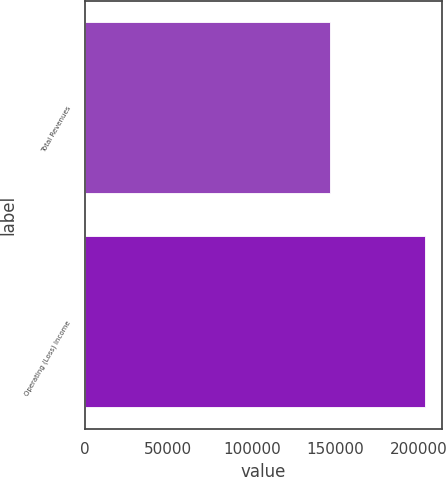<chart> <loc_0><loc_0><loc_500><loc_500><bar_chart><fcel>Total Revenues<fcel>Operating (Loss) Income<nl><fcel>146801<fcel>203480<nl></chart> 